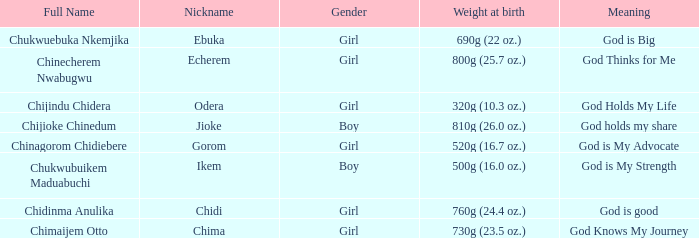Could you help me parse every detail presented in this table? {'header': ['Full Name', 'Nickname', 'Gender', 'Weight at birth', 'Meaning'], 'rows': [['Chukwuebuka Nkemjika', 'Ebuka', 'Girl', '690g (22 oz.)', 'God is Big'], ['Chinecherem Nwabugwu', 'Echerem', 'Girl', '800g (25.7 oz.)', 'God Thinks for Me'], ['Chijindu Chidera', 'Odera', 'Girl', '320g (10.3 oz.)', 'God Holds My Life'], ['Chijioke Chinedum', 'Jioke', 'Boy', '810g (26.0 oz.)', 'God holds my share'], ['Chinagorom Chidiebere', 'Gorom', 'Girl', '520g (16.7 oz.)', 'God is My Advocate'], ['Chukwubuikem Maduabuchi', 'Ikem', 'Boy', '500g (16.0 oz.)', 'God is My Strength'], ['Chidinma Anulika', 'Chidi', 'Girl', '760g (24.4 oz.)', 'God is good'], ['Chimaijem Otto', 'Chima', 'Girl', '730g (23.5 oz.)', 'God Knows My Journey']]} What nickname has the meaning of God knows my journey? Chima. 